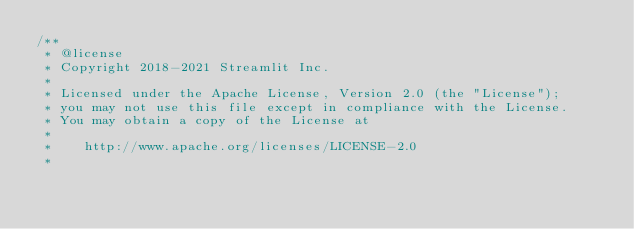<code> <loc_0><loc_0><loc_500><loc_500><_TypeScript_>/**
 * @license
 * Copyright 2018-2021 Streamlit Inc.
 *
 * Licensed under the Apache License, Version 2.0 (the "License");
 * you may not use this file except in compliance with the License.
 * You may obtain a copy of the License at
 *
 *    http://www.apache.org/licenses/LICENSE-2.0
 *</code> 